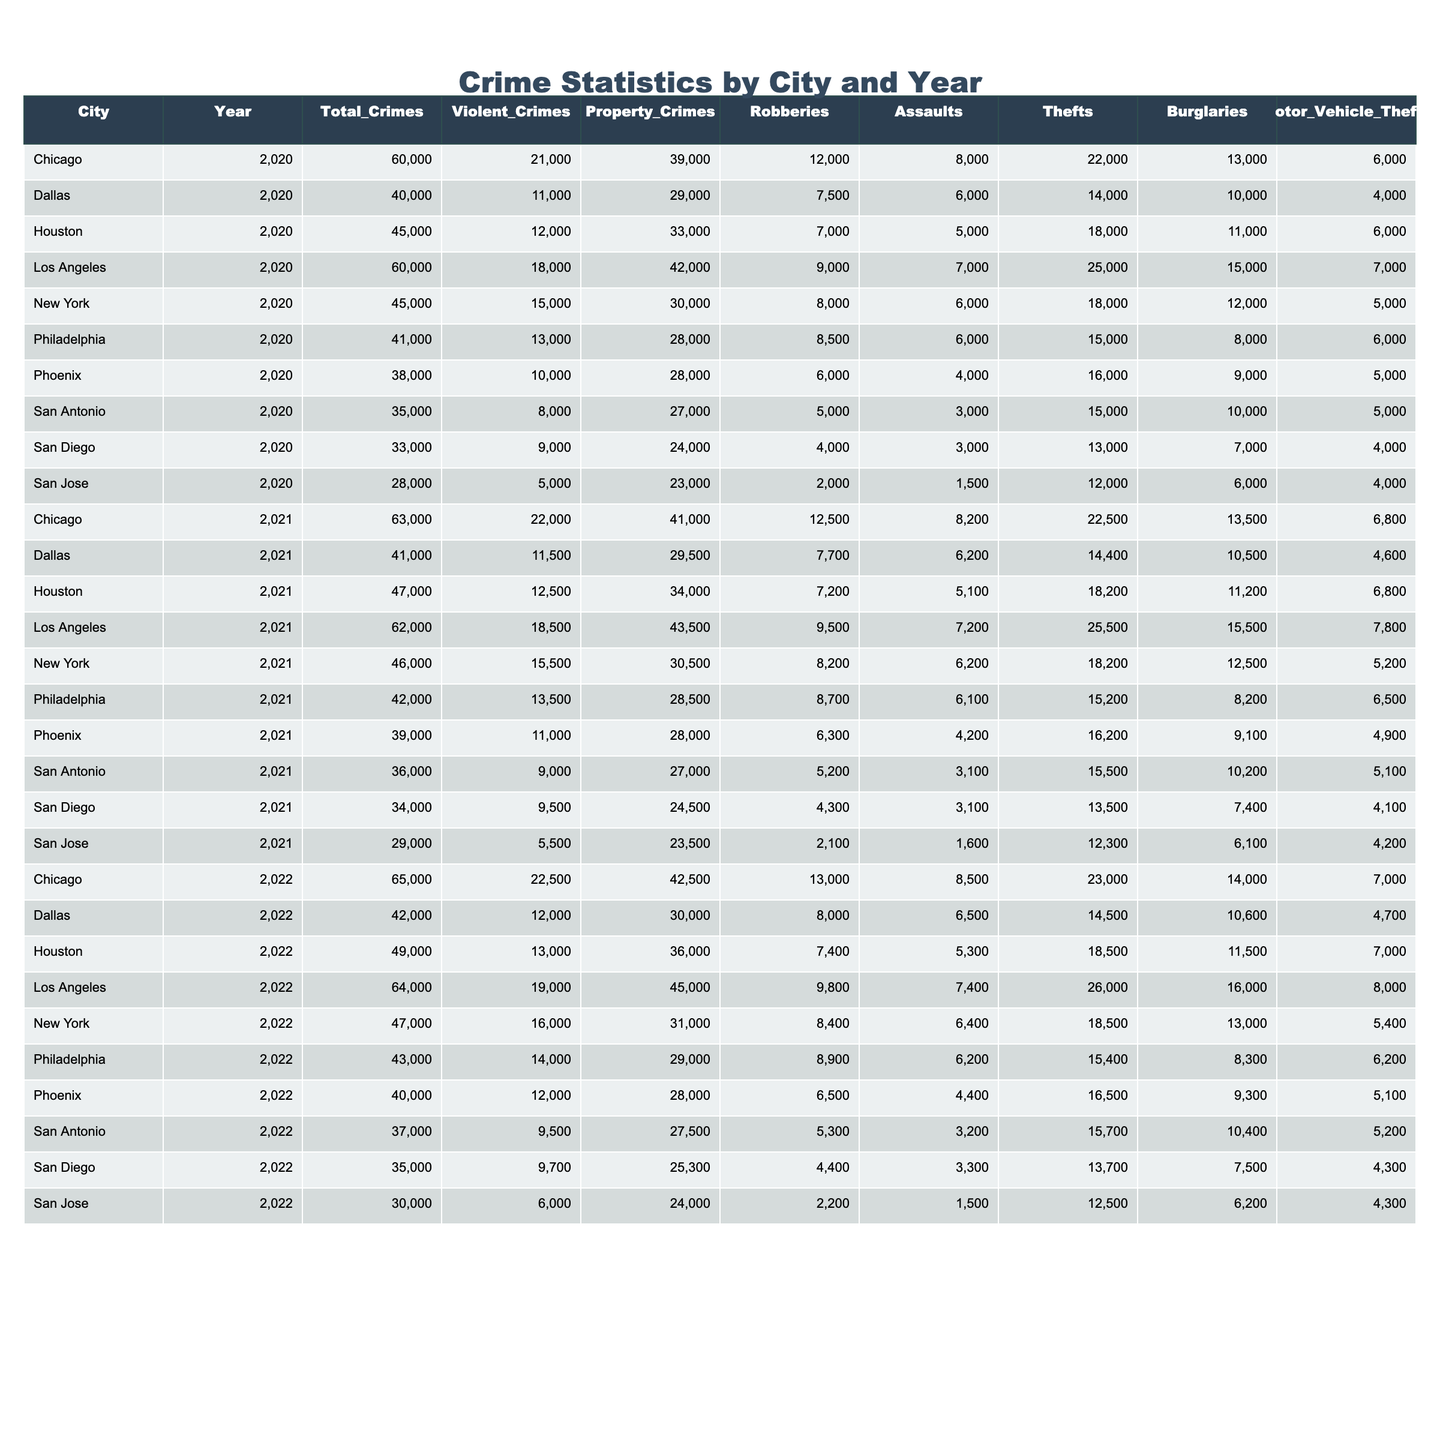What city had the highest total crimes in 2020? Looking at the total crimes column for 2020, Los Angeles has the highest figure with 60,000 total crimes.
Answer: Los Angeles Which city experienced an increase in violent crimes from 2020 to 2021? Comparing the violent crimes in both years, Chicago had an increase from 21,000 in 2020 to 22,000 in 2021.
Answer: Yes, Chicago What was the average number of property crimes across all cities in 2022? To find the average, sum all the property crimes for 2022: (31,000 + 45,000 + 42,500 + 36,000 + 29,000 + 28,000 + 27,500 + 25,300 + 30,000 + 24,000) which equals  42,500 / 10 = 42,500
Answer: 42,500 Did Philadelphia have more robberies than Houston in 2021? In 2021, Philadelphia had 8,700 robberies and Houston had 7,200. Since 8,700 is greater than 7,200, Philadelphia did have more.
Answer: Yes What is the difference in total crimes between New York and Los Angeles in 2022? New York had 47,000 total crimes and Los Angeles had 64,000; the difference is 64,000 - 47,000 = 17,000.
Answer: 17,000 Which city had the most motor vehicle thefts in 2021? Checking the motor vehicle theft numbers, Los Angeles had the highest at 7,800 in 2021.
Answer: Los Angeles What trend can be observed in total crimes for Chicago from 2020 to 2022? Chicago's total crimes increased from 60,000 in 2020 to 65,000 in 2022, indicating a rising trend.
Answer: Rising trend What percentage of total crimes in San Antonio in 2021 were violent crimes? In 2021, San Antonio had 36,000 total crimes and 9,000 violent crimes, so the percentage is (9,000 / 36,000) * 100 = 25%.
Answer: 25% Which city had the least number of total crimes in 2020? In 2020, San Jose had the least number of total crimes with 28,000.
Answer: San Jose Is the number of assaults in New York decreasing from 2020 to 2022? The number of assaults in New York increased from 6,000 in 2020 to 6,400 in 2021 and then to 6,400 in 2022. Therefore, it is not decreasing.
Answer: No, it is not decreasing 